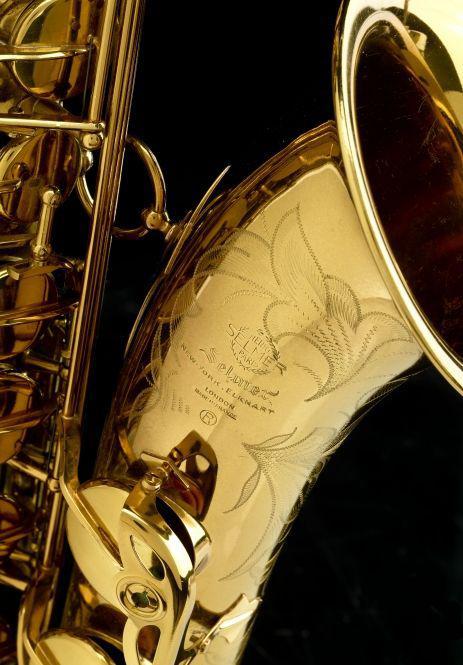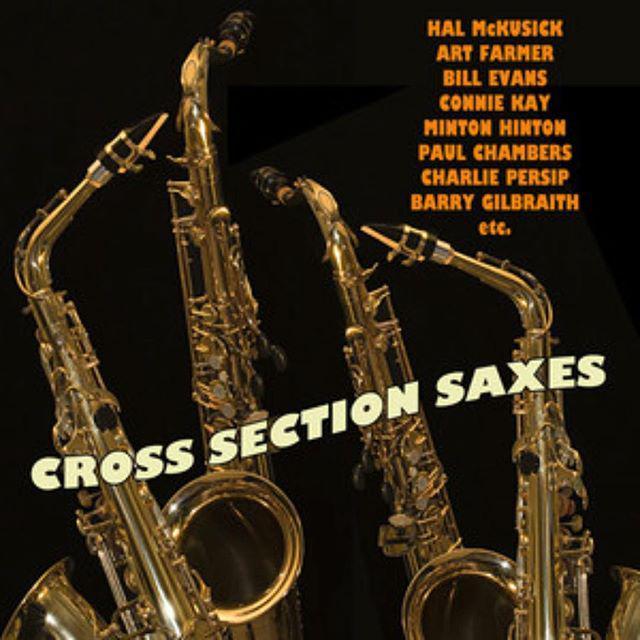The first image is the image on the left, the second image is the image on the right. For the images displayed, is the sentence "At least one image includes a keyboard in a scene with a saxophone." factually correct? Answer yes or no. No. The first image is the image on the left, the second image is the image on the right. Assess this claim about the two images: "The only instruments shown are woodwinds.". Correct or not? Answer yes or no. Yes. 